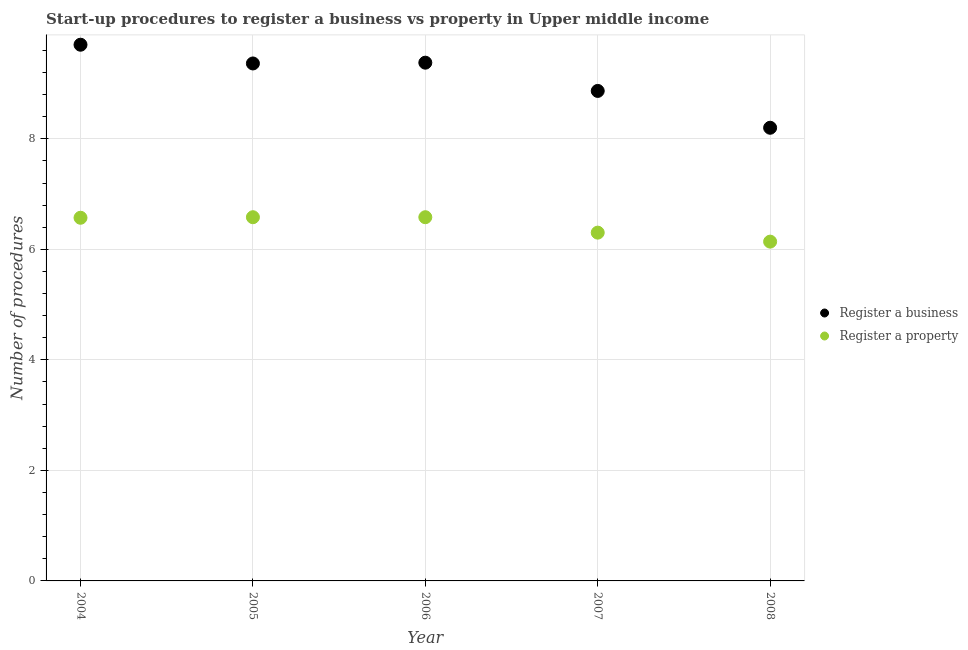How many different coloured dotlines are there?
Your response must be concise. 2. Across all years, what is the maximum number of procedures to register a business?
Give a very brief answer. 9.7. What is the total number of procedures to register a property in the graph?
Provide a short and direct response. 32.18. What is the difference between the number of procedures to register a property in 2004 and that in 2005?
Provide a succinct answer. -0.01. What is the difference between the number of procedures to register a business in 2008 and the number of procedures to register a property in 2004?
Provide a short and direct response. 1.63. What is the average number of procedures to register a business per year?
Your response must be concise. 9.1. In the year 2005, what is the difference between the number of procedures to register a business and number of procedures to register a property?
Ensure brevity in your answer.  2.78. In how many years, is the number of procedures to register a property greater than 1.6?
Give a very brief answer. 5. What is the ratio of the number of procedures to register a property in 2006 to that in 2007?
Your answer should be very brief. 1.04. Is the number of procedures to register a property in 2007 less than that in 2008?
Offer a terse response. No. Is the difference between the number of procedures to register a business in 2006 and 2007 greater than the difference between the number of procedures to register a property in 2006 and 2007?
Provide a short and direct response. Yes. What is the difference between the highest and the second highest number of procedures to register a business?
Give a very brief answer. 0.32. What is the difference between the highest and the lowest number of procedures to register a business?
Ensure brevity in your answer.  1.5. In how many years, is the number of procedures to register a property greater than the average number of procedures to register a property taken over all years?
Offer a terse response. 3. Is the sum of the number of procedures to register a property in 2005 and 2007 greater than the maximum number of procedures to register a business across all years?
Your answer should be very brief. Yes. Is the number of procedures to register a business strictly less than the number of procedures to register a property over the years?
Offer a terse response. No. How many years are there in the graph?
Make the answer very short. 5. What is the difference between two consecutive major ticks on the Y-axis?
Your answer should be very brief. 2. Are the values on the major ticks of Y-axis written in scientific E-notation?
Offer a very short reply. No. Does the graph contain any zero values?
Your answer should be very brief. No. What is the title of the graph?
Make the answer very short. Start-up procedures to register a business vs property in Upper middle income. Does "Taxes on profits and capital gains" appear as one of the legend labels in the graph?
Your answer should be compact. No. What is the label or title of the X-axis?
Your answer should be very brief. Year. What is the label or title of the Y-axis?
Offer a terse response. Number of procedures. What is the Number of procedures in Register a business in 2004?
Your answer should be compact. 9.7. What is the Number of procedures in Register a property in 2004?
Keep it short and to the point. 6.57. What is the Number of procedures in Register a business in 2005?
Give a very brief answer. 9.36. What is the Number of procedures in Register a property in 2005?
Your answer should be very brief. 6.58. What is the Number of procedures of Register a business in 2006?
Provide a short and direct response. 9.38. What is the Number of procedures in Register a property in 2006?
Offer a very short reply. 6.58. What is the Number of procedures of Register a business in 2007?
Your answer should be very brief. 8.87. What is the Number of procedures of Register a property in 2007?
Your answer should be very brief. 6.3. What is the Number of procedures of Register a business in 2008?
Keep it short and to the point. 8.2. What is the Number of procedures in Register a property in 2008?
Your answer should be compact. 6.14. Across all years, what is the maximum Number of procedures in Register a business?
Keep it short and to the point. 9.7. Across all years, what is the maximum Number of procedures of Register a property?
Your answer should be compact. 6.58. Across all years, what is the minimum Number of procedures of Register a business?
Offer a terse response. 8.2. Across all years, what is the minimum Number of procedures of Register a property?
Your answer should be very brief. 6.14. What is the total Number of procedures in Register a business in the graph?
Your answer should be very brief. 45.51. What is the total Number of procedures in Register a property in the graph?
Your answer should be compact. 32.18. What is the difference between the Number of procedures in Register a business in 2004 and that in 2005?
Your answer should be very brief. 0.34. What is the difference between the Number of procedures in Register a property in 2004 and that in 2005?
Your response must be concise. -0.01. What is the difference between the Number of procedures in Register a business in 2004 and that in 2006?
Offer a terse response. 0.32. What is the difference between the Number of procedures in Register a property in 2004 and that in 2006?
Your answer should be very brief. -0.01. What is the difference between the Number of procedures in Register a business in 2004 and that in 2007?
Offer a terse response. 0.84. What is the difference between the Number of procedures in Register a property in 2004 and that in 2007?
Your response must be concise. 0.27. What is the difference between the Number of procedures of Register a business in 2004 and that in 2008?
Give a very brief answer. 1.5. What is the difference between the Number of procedures of Register a property in 2004 and that in 2008?
Your response must be concise. 0.43. What is the difference between the Number of procedures of Register a business in 2005 and that in 2006?
Give a very brief answer. -0.01. What is the difference between the Number of procedures in Register a property in 2005 and that in 2006?
Provide a short and direct response. 0. What is the difference between the Number of procedures in Register a business in 2005 and that in 2007?
Your response must be concise. 0.5. What is the difference between the Number of procedures in Register a property in 2005 and that in 2007?
Make the answer very short. 0.28. What is the difference between the Number of procedures of Register a business in 2005 and that in 2008?
Keep it short and to the point. 1.16. What is the difference between the Number of procedures in Register a property in 2005 and that in 2008?
Your response must be concise. 0.44. What is the difference between the Number of procedures in Register a business in 2006 and that in 2007?
Offer a terse response. 0.51. What is the difference between the Number of procedures of Register a property in 2006 and that in 2007?
Your answer should be very brief. 0.28. What is the difference between the Number of procedures in Register a business in 2006 and that in 2008?
Keep it short and to the point. 1.18. What is the difference between the Number of procedures in Register a property in 2006 and that in 2008?
Your answer should be very brief. 0.44. What is the difference between the Number of procedures in Register a property in 2007 and that in 2008?
Make the answer very short. 0.16. What is the difference between the Number of procedures of Register a business in 2004 and the Number of procedures of Register a property in 2005?
Keep it short and to the point. 3.12. What is the difference between the Number of procedures in Register a business in 2004 and the Number of procedures in Register a property in 2006?
Your answer should be very brief. 3.12. What is the difference between the Number of procedures of Register a business in 2004 and the Number of procedures of Register a property in 2007?
Your answer should be very brief. 3.4. What is the difference between the Number of procedures in Register a business in 2004 and the Number of procedures in Register a property in 2008?
Make the answer very short. 3.56. What is the difference between the Number of procedures of Register a business in 2005 and the Number of procedures of Register a property in 2006?
Keep it short and to the point. 2.78. What is the difference between the Number of procedures of Register a business in 2005 and the Number of procedures of Register a property in 2007?
Keep it short and to the point. 3.06. What is the difference between the Number of procedures in Register a business in 2005 and the Number of procedures in Register a property in 2008?
Your answer should be very brief. 3.22. What is the difference between the Number of procedures in Register a business in 2006 and the Number of procedures in Register a property in 2007?
Ensure brevity in your answer.  3.08. What is the difference between the Number of procedures in Register a business in 2006 and the Number of procedures in Register a property in 2008?
Provide a succinct answer. 3.24. What is the difference between the Number of procedures in Register a business in 2007 and the Number of procedures in Register a property in 2008?
Your answer should be very brief. 2.73. What is the average Number of procedures in Register a business per year?
Your response must be concise. 9.1. What is the average Number of procedures in Register a property per year?
Provide a succinct answer. 6.44. In the year 2004, what is the difference between the Number of procedures of Register a business and Number of procedures of Register a property?
Make the answer very short. 3.13. In the year 2005, what is the difference between the Number of procedures of Register a business and Number of procedures of Register a property?
Keep it short and to the point. 2.78. In the year 2006, what is the difference between the Number of procedures in Register a business and Number of procedures in Register a property?
Offer a terse response. 2.8. In the year 2007, what is the difference between the Number of procedures of Register a business and Number of procedures of Register a property?
Provide a short and direct response. 2.56. In the year 2008, what is the difference between the Number of procedures of Register a business and Number of procedures of Register a property?
Give a very brief answer. 2.06. What is the ratio of the Number of procedures in Register a business in 2004 to that in 2005?
Offer a terse response. 1.04. What is the ratio of the Number of procedures in Register a business in 2004 to that in 2006?
Give a very brief answer. 1.03. What is the ratio of the Number of procedures of Register a property in 2004 to that in 2006?
Ensure brevity in your answer.  1. What is the ratio of the Number of procedures of Register a business in 2004 to that in 2007?
Your answer should be very brief. 1.09. What is the ratio of the Number of procedures of Register a property in 2004 to that in 2007?
Your answer should be compact. 1.04. What is the ratio of the Number of procedures of Register a business in 2004 to that in 2008?
Make the answer very short. 1.18. What is the ratio of the Number of procedures in Register a property in 2004 to that in 2008?
Provide a short and direct response. 1.07. What is the ratio of the Number of procedures of Register a business in 2005 to that in 2007?
Your answer should be very brief. 1.06. What is the ratio of the Number of procedures in Register a property in 2005 to that in 2007?
Offer a very short reply. 1.04. What is the ratio of the Number of procedures in Register a business in 2005 to that in 2008?
Keep it short and to the point. 1.14. What is the ratio of the Number of procedures of Register a property in 2005 to that in 2008?
Provide a succinct answer. 1.07. What is the ratio of the Number of procedures of Register a business in 2006 to that in 2007?
Give a very brief answer. 1.06. What is the ratio of the Number of procedures of Register a property in 2006 to that in 2007?
Your answer should be compact. 1.04. What is the ratio of the Number of procedures in Register a business in 2006 to that in 2008?
Your response must be concise. 1.14. What is the ratio of the Number of procedures of Register a property in 2006 to that in 2008?
Your answer should be very brief. 1.07. What is the ratio of the Number of procedures of Register a business in 2007 to that in 2008?
Your answer should be compact. 1.08. What is the ratio of the Number of procedures of Register a property in 2007 to that in 2008?
Give a very brief answer. 1.03. What is the difference between the highest and the second highest Number of procedures in Register a business?
Your answer should be very brief. 0.32. What is the difference between the highest and the second highest Number of procedures in Register a property?
Offer a terse response. 0. What is the difference between the highest and the lowest Number of procedures of Register a business?
Keep it short and to the point. 1.5. What is the difference between the highest and the lowest Number of procedures in Register a property?
Keep it short and to the point. 0.44. 